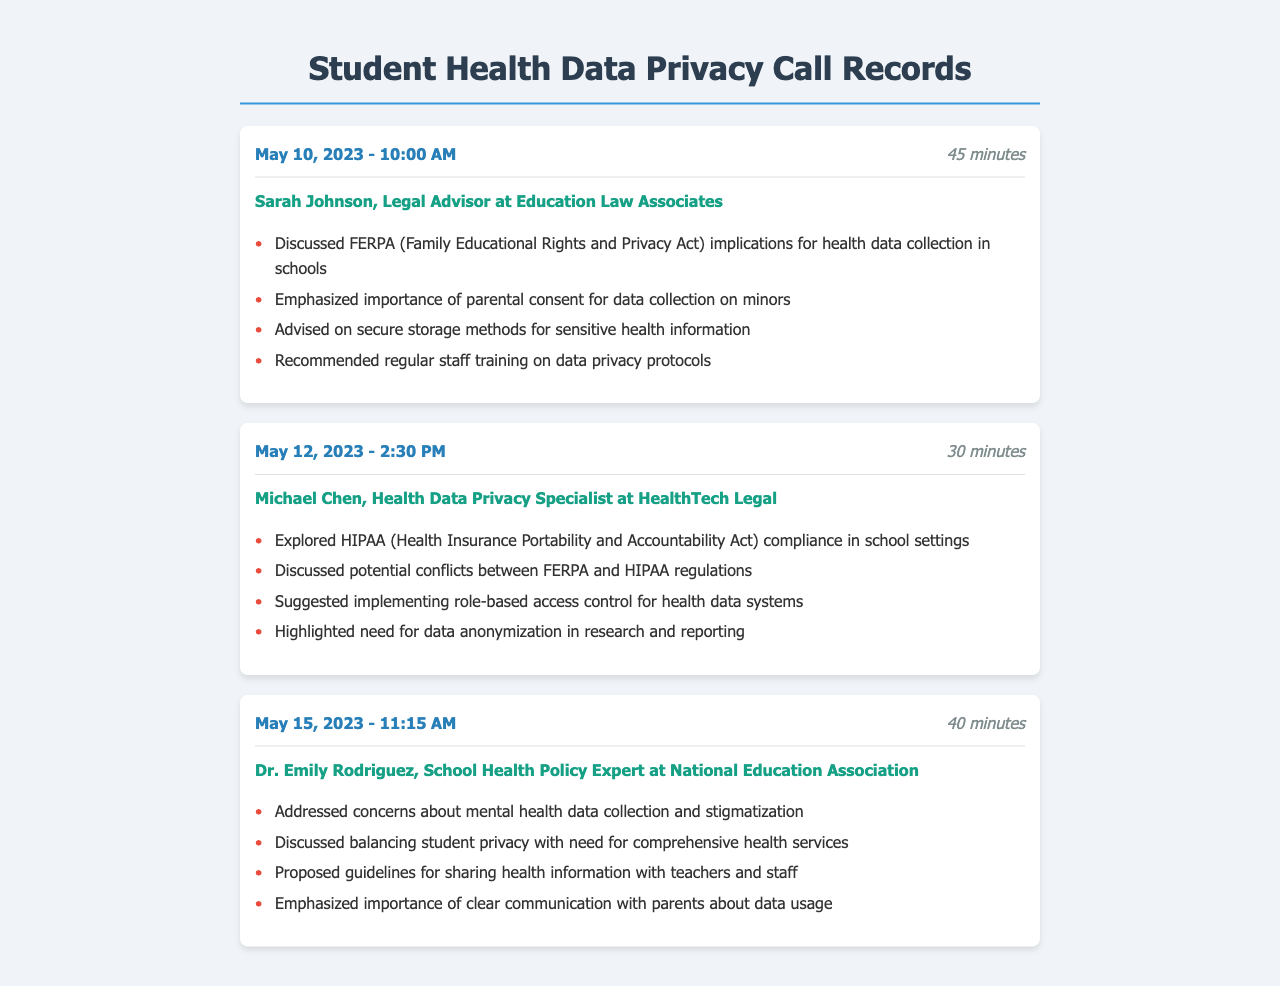What is the date of the first call? The first call is recorded on May 10, 2023.
Answer: May 10, 2023 Who is the participant in the second call? The second call includes Michael Chen, a Health Data Privacy Specialist.
Answer: Michael Chen What is one of the privacy regulations discussed in the first call? The first call discusses the implications of FERPA for health data collection in schools.
Answer: FERPA How long did the call with Dr. Emily Rodriguez last? The call duration for Dr. Emily Rodriguez's call was 40 minutes.
Answer: 40 minutes What key concern was addressed in the call with Dr. Emily Rodriguez? The call addresses concerns about mental health data collection and stigmatization.
Answer: Mental health data collection and stigmatization What is the primary focus of the second call? The primary focus of the second call is on HIPAA compliance in school settings.
Answer: HIPAA compliance What storage recommendation was made in the first call? The recommendation made was about secure storage methods for sensitive health information.
Answer: Secure storage methods What type of access control was suggested in the second call? The suggestion was to implement role-based access control for health data systems.
Answer: Role-based access control 